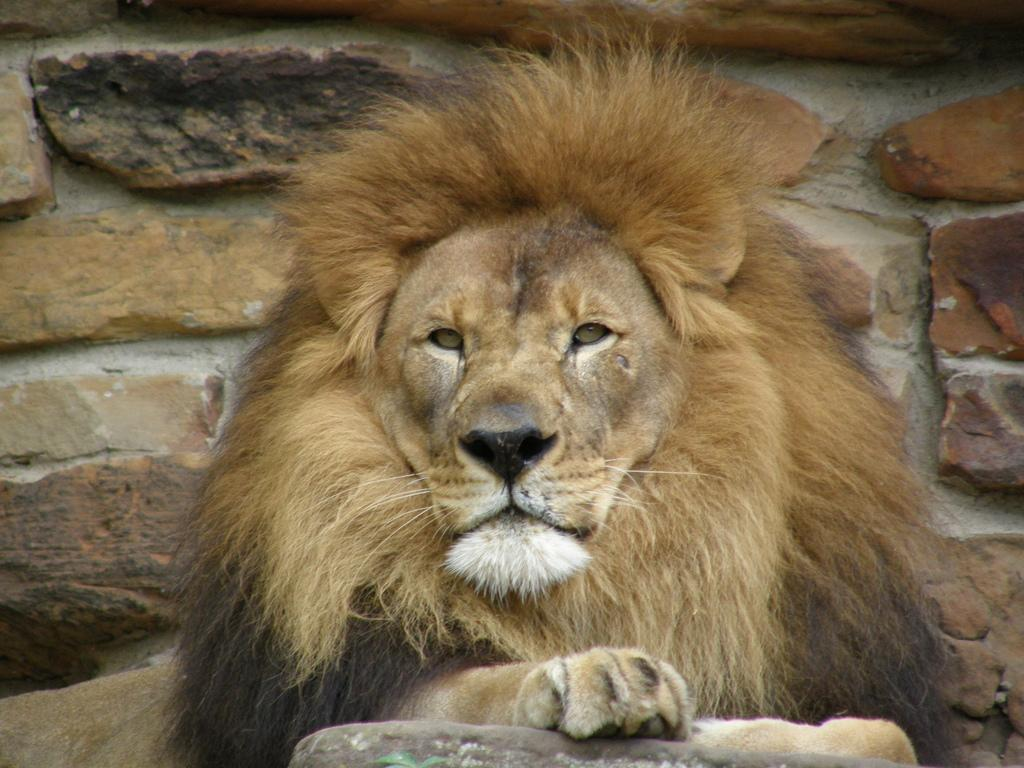What animal is present in the image? There is a lion in the image. What can be seen in the background of the image? There is a brick wall in the background of the image. What type of knife is being used to cut the pan in the image? There is no knife, pan, or cutting activity present in the image; it features a lion and a brick wall. 